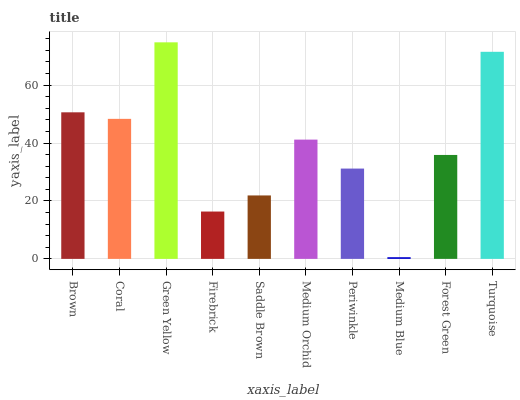Is Medium Blue the minimum?
Answer yes or no. Yes. Is Green Yellow the maximum?
Answer yes or no. Yes. Is Coral the minimum?
Answer yes or no. No. Is Coral the maximum?
Answer yes or no. No. Is Brown greater than Coral?
Answer yes or no. Yes. Is Coral less than Brown?
Answer yes or no. Yes. Is Coral greater than Brown?
Answer yes or no. No. Is Brown less than Coral?
Answer yes or no. No. Is Medium Orchid the high median?
Answer yes or no. Yes. Is Forest Green the low median?
Answer yes or no. Yes. Is Medium Blue the high median?
Answer yes or no. No. Is Medium Blue the low median?
Answer yes or no. No. 